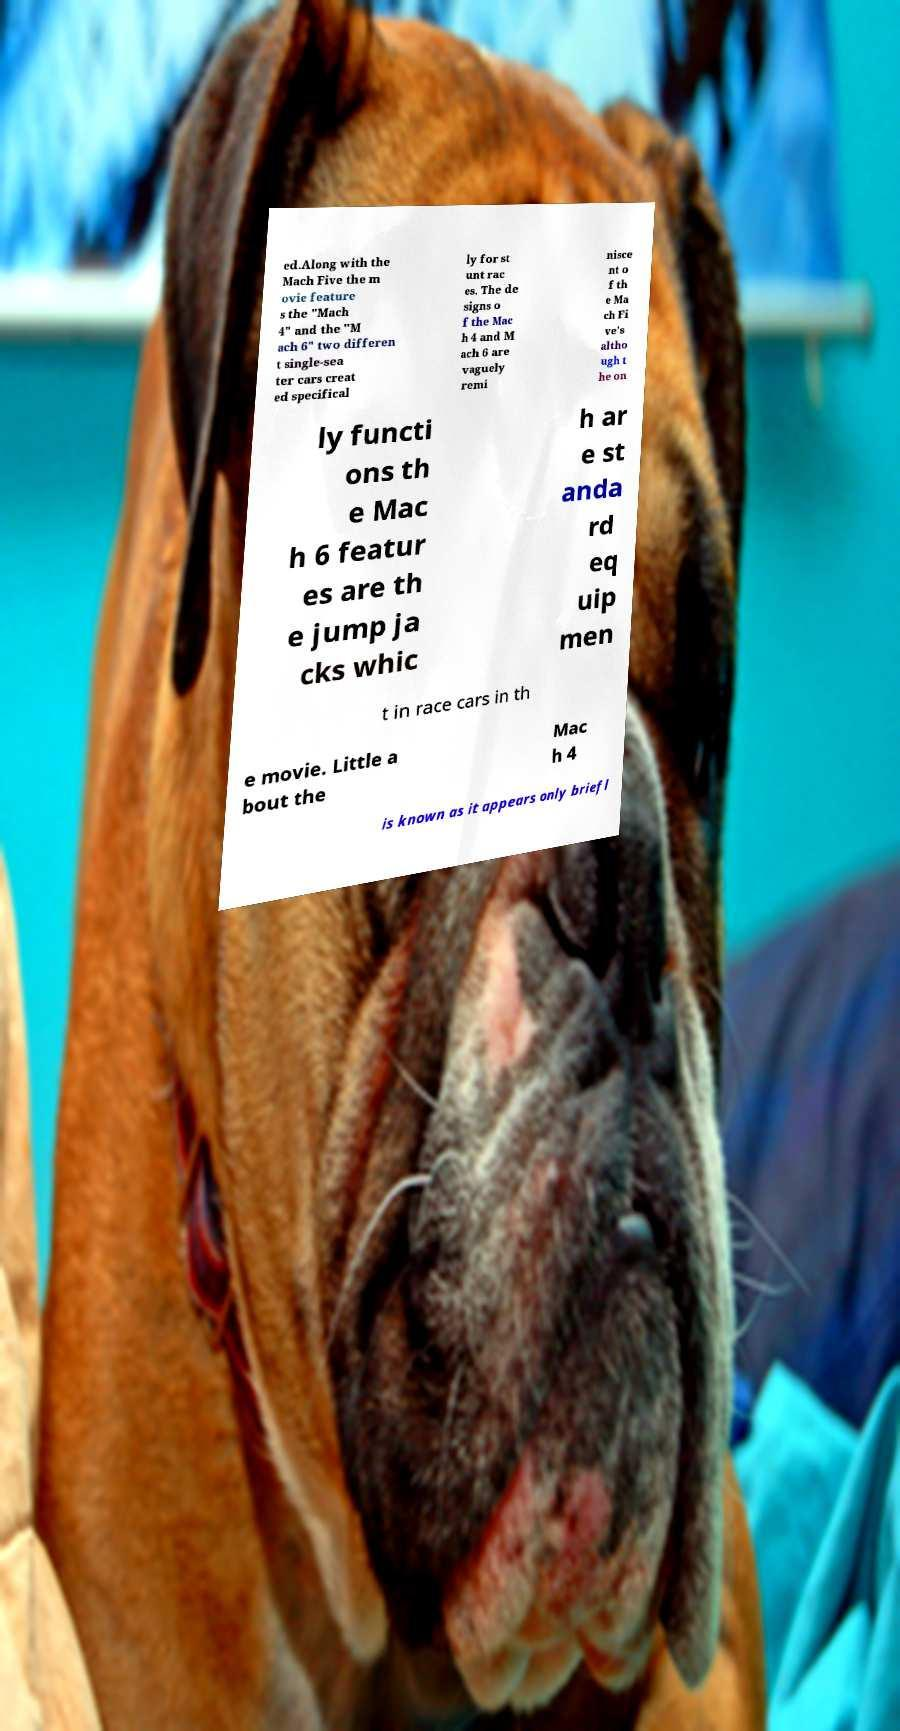Please read and relay the text visible in this image. What does it say? ed.Along with the Mach Five the m ovie feature s the "Mach 4" and the "M ach 6" two differen t single-sea ter cars creat ed specifical ly for st unt rac es. The de signs o f the Mac h 4 and M ach 6 are vaguely remi nisce nt o f th e Ma ch Fi ve's altho ugh t he on ly functi ons th e Mac h 6 featur es are th e jump ja cks whic h ar e st anda rd eq uip men t in race cars in th e movie. Little a bout the Mac h 4 is known as it appears only briefl 